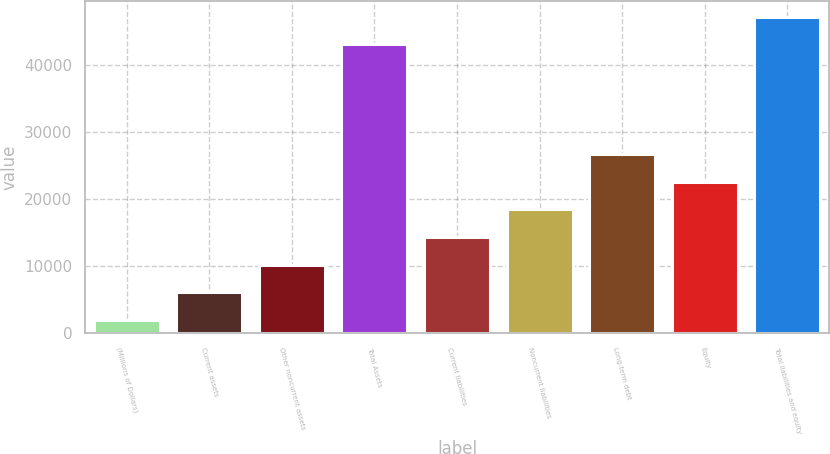Convert chart to OTSL. <chart><loc_0><loc_0><loc_500><loc_500><bar_chart><fcel>(Millions of Dollars)<fcel>Current assets<fcel>Other noncurrent assets<fcel>Total Assets<fcel>Current liabilities<fcel>Noncurrent liabilities<fcel>Long-term debt<fcel>Equity<fcel>Total liabilities and equity<nl><fcel>2018<fcel>6127<fcel>10236<fcel>43108<fcel>14345<fcel>18454<fcel>26672<fcel>22563<fcel>47217<nl></chart> 